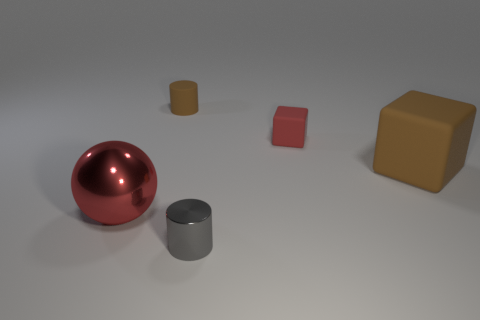What is the shape of the tiny rubber thing that is the same color as the metal sphere?
Your answer should be very brief. Cube. There is a brown object that is to the right of the gray object; is there a small red rubber thing in front of it?
Ensure brevity in your answer.  No. What is the thing that is to the right of the gray cylinder and to the left of the big matte object made of?
Offer a very short reply. Rubber. There is a matte thing that is in front of the cube on the left side of the big rubber object that is on the right side of the big red ball; what color is it?
Provide a short and direct response. Brown. There is a cube that is the same size as the gray metal cylinder; what color is it?
Your answer should be very brief. Red. Is the color of the small rubber cylinder the same as the rubber object that is on the right side of the small red object?
Make the answer very short. Yes. What is the material of the block that is left of the matte cube that is in front of the tiny block?
Offer a very short reply. Rubber. How many objects are both behind the small gray cylinder and left of the large brown object?
Offer a very short reply. 3. What number of other things are there of the same size as the ball?
Offer a terse response. 1. Is the shape of the brown thing that is behind the tiny red object the same as the brown thing that is on the right side of the shiny cylinder?
Give a very brief answer. No. 